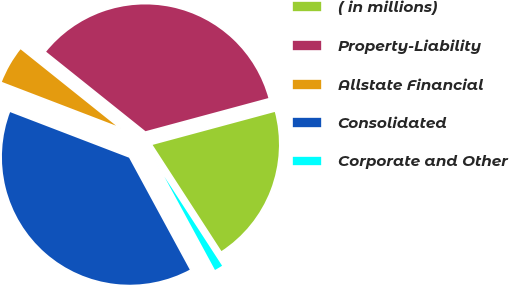Convert chart to OTSL. <chart><loc_0><loc_0><loc_500><loc_500><pie_chart><fcel>( in millions)<fcel>Property-Liability<fcel>Allstate Financial<fcel>Consolidated<fcel>Corporate and Other<nl><fcel>20.04%<fcel>35.07%<fcel>4.91%<fcel>38.74%<fcel>1.24%<nl></chart> 